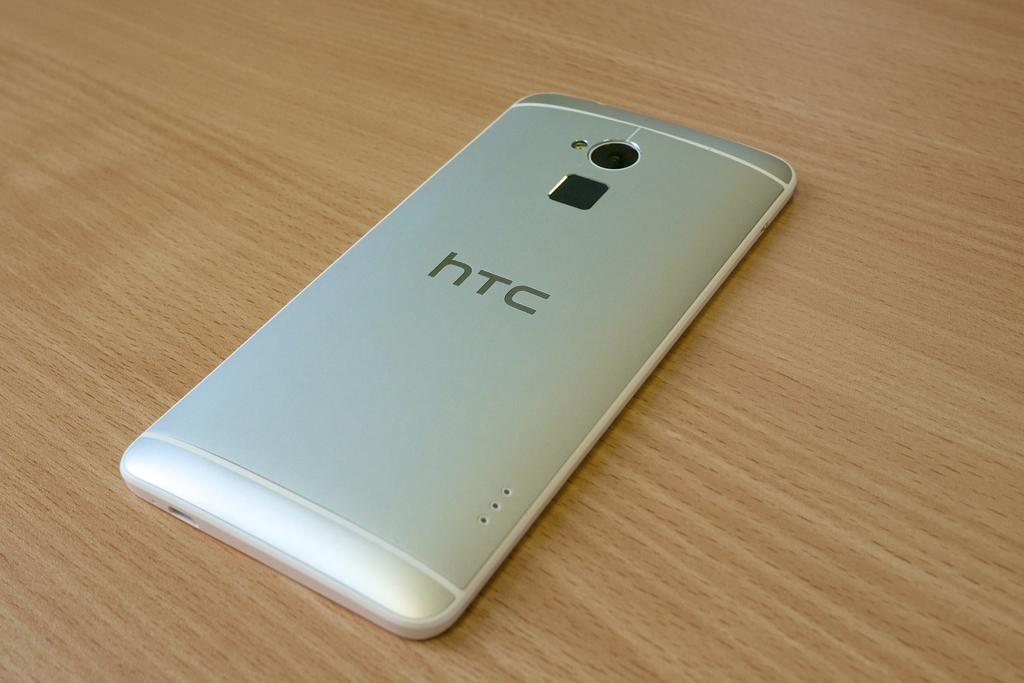<image>
Share a concise interpretation of the image provided. An htc electronic device turned on it's front on a laminate table or counter. 